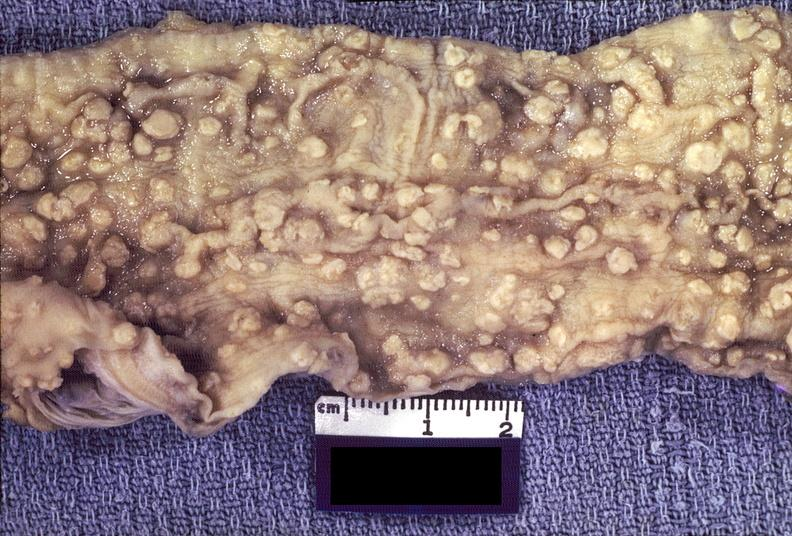where does this belong to?
Answer the question using a single word or phrase. Gastrointestinal system 